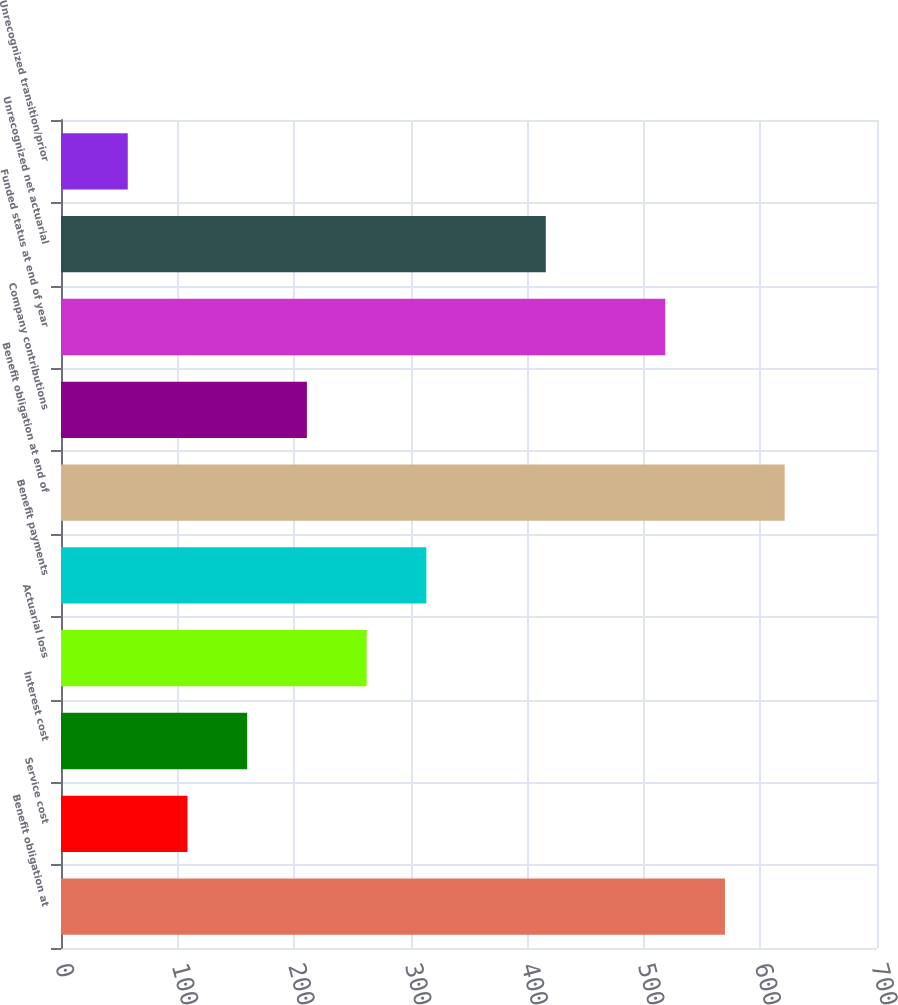<chart> <loc_0><loc_0><loc_500><loc_500><bar_chart><fcel>Benefit obligation at<fcel>Service cost<fcel>Interest cost<fcel>Actuarial loss<fcel>Benefit payments<fcel>Benefit obligation at end of<fcel>Company contributions<fcel>Funded status at end of year<fcel>Unrecognized net actuarial<fcel>Unrecognized transition/prior<nl><fcel>569.56<fcel>108.49<fcel>159.72<fcel>262.18<fcel>313.41<fcel>620.79<fcel>210.95<fcel>518.33<fcel>415.87<fcel>57.26<nl></chart> 